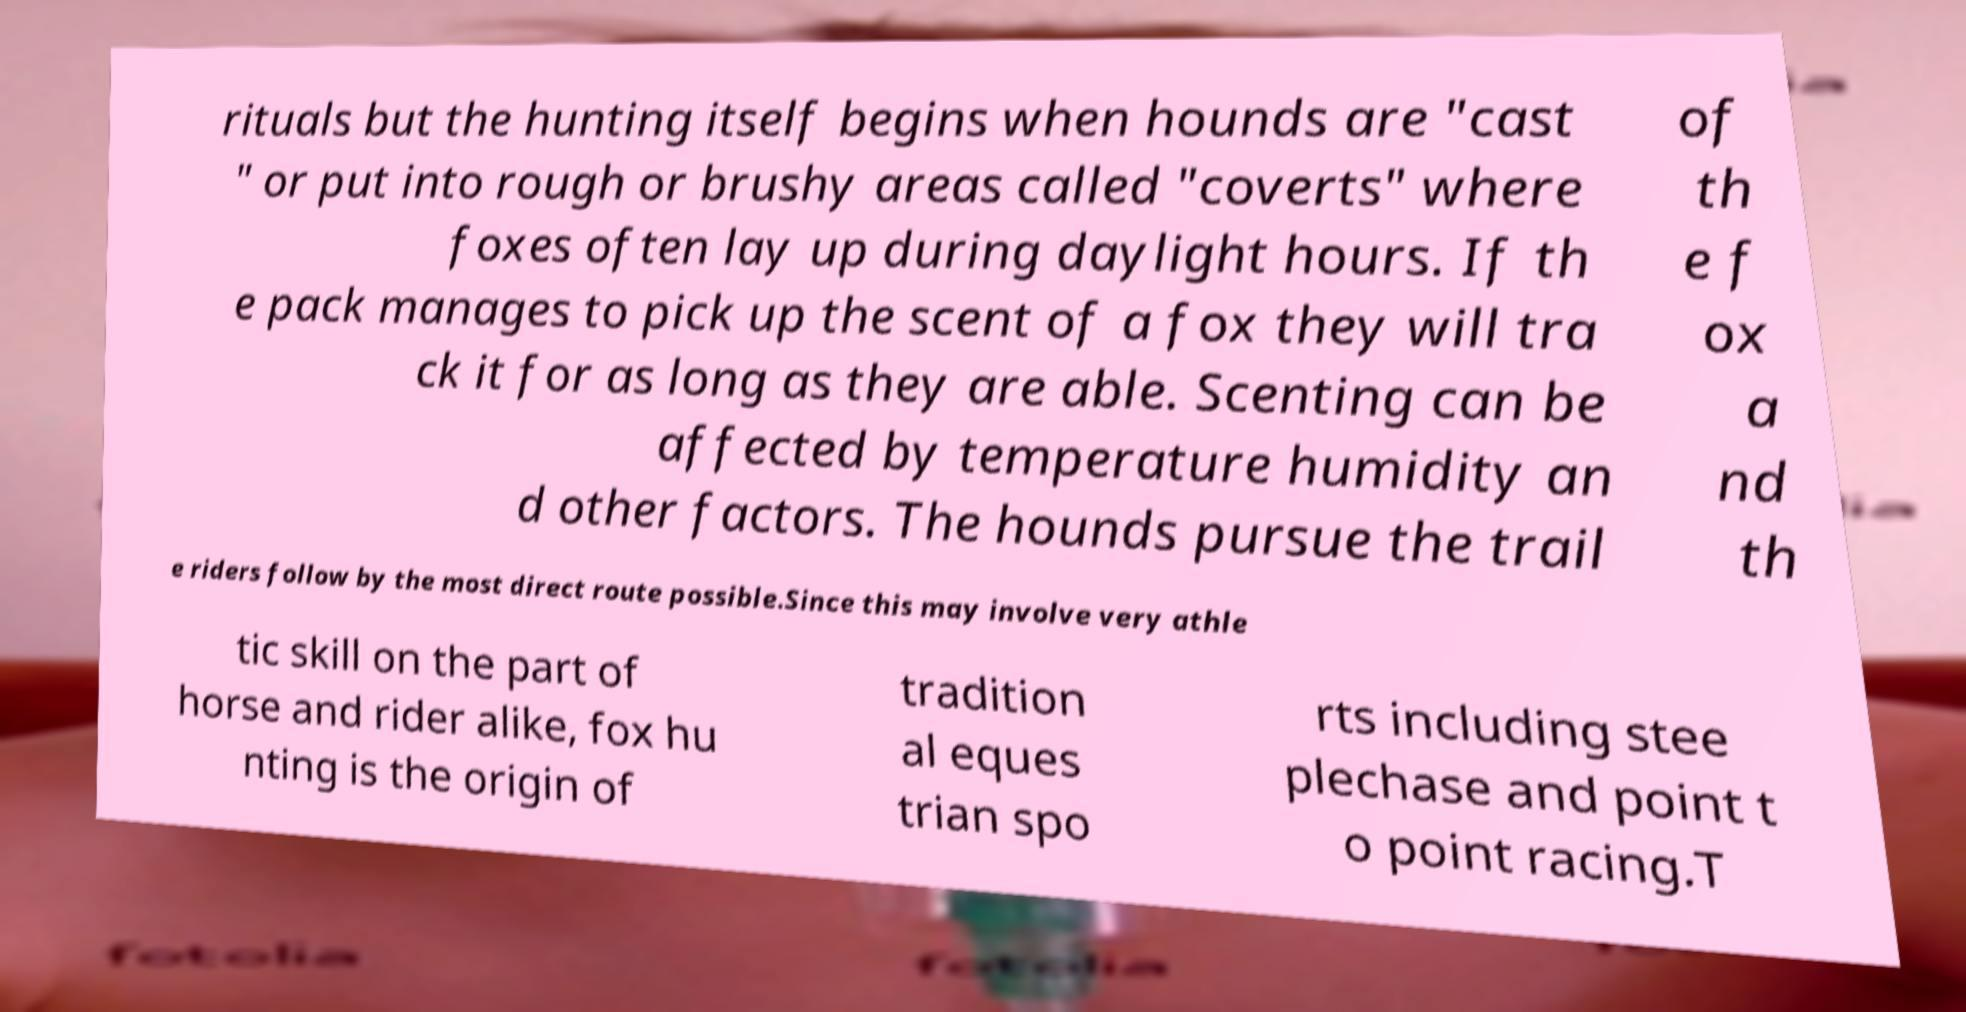Can you accurately transcribe the text from the provided image for me? rituals but the hunting itself begins when hounds are "cast " or put into rough or brushy areas called "coverts" where foxes often lay up during daylight hours. If th e pack manages to pick up the scent of a fox they will tra ck it for as long as they are able. Scenting can be affected by temperature humidity an d other factors. The hounds pursue the trail of th e f ox a nd th e riders follow by the most direct route possible.Since this may involve very athle tic skill on the part of horse and rider alike, fox hu nting is the origin of tradition al eques trian spo rts including stee plechase and point t o point racing.T 